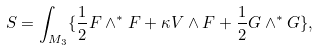<formula> <loc_0><loc_0><loc_500><loc_500>S = \int _ { M _ { 3 } } \{ \frac { 1 } { 2 } F \wedge ^ { * } F + \kappa V \wedge F + \frac { 1 } { 2 } G \wedge ^ { * } G \} ,</formula> 